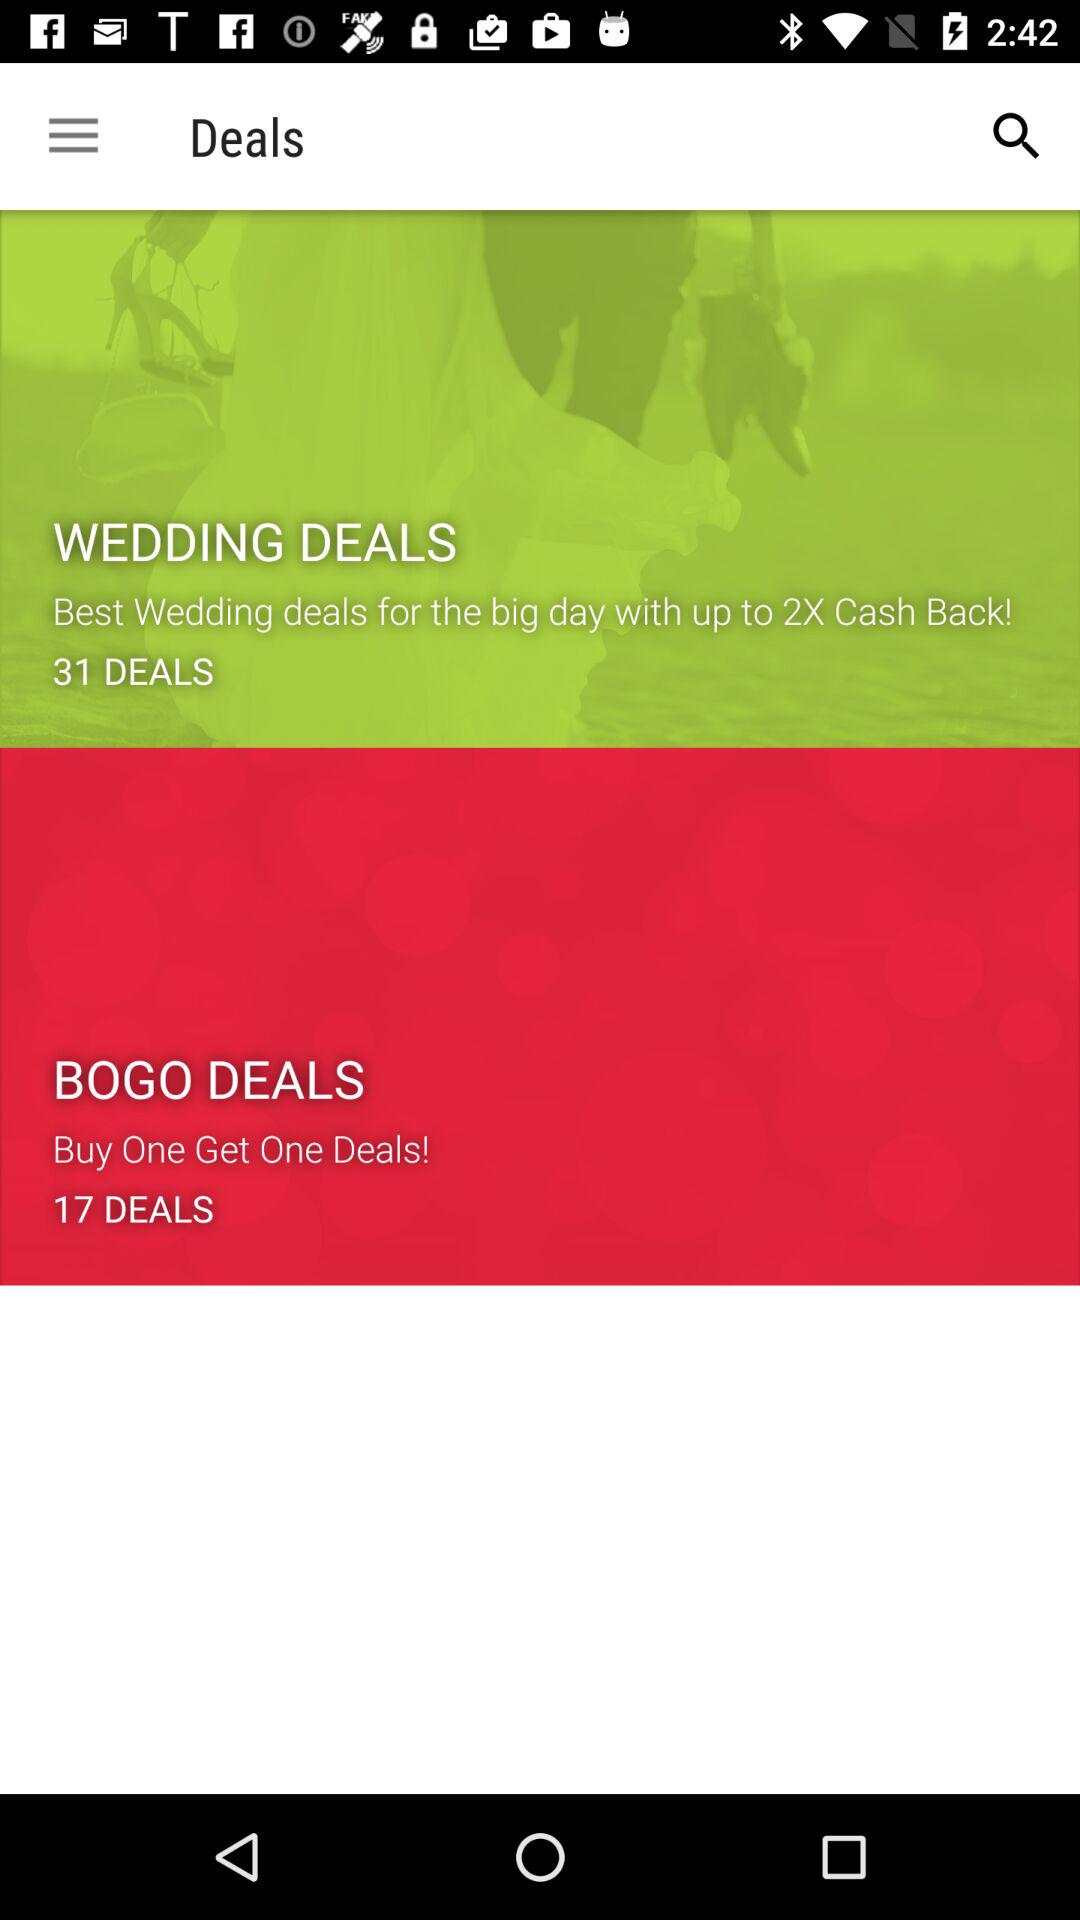What is the total number of deals for "BOGO"? The total number of deals is 17. 